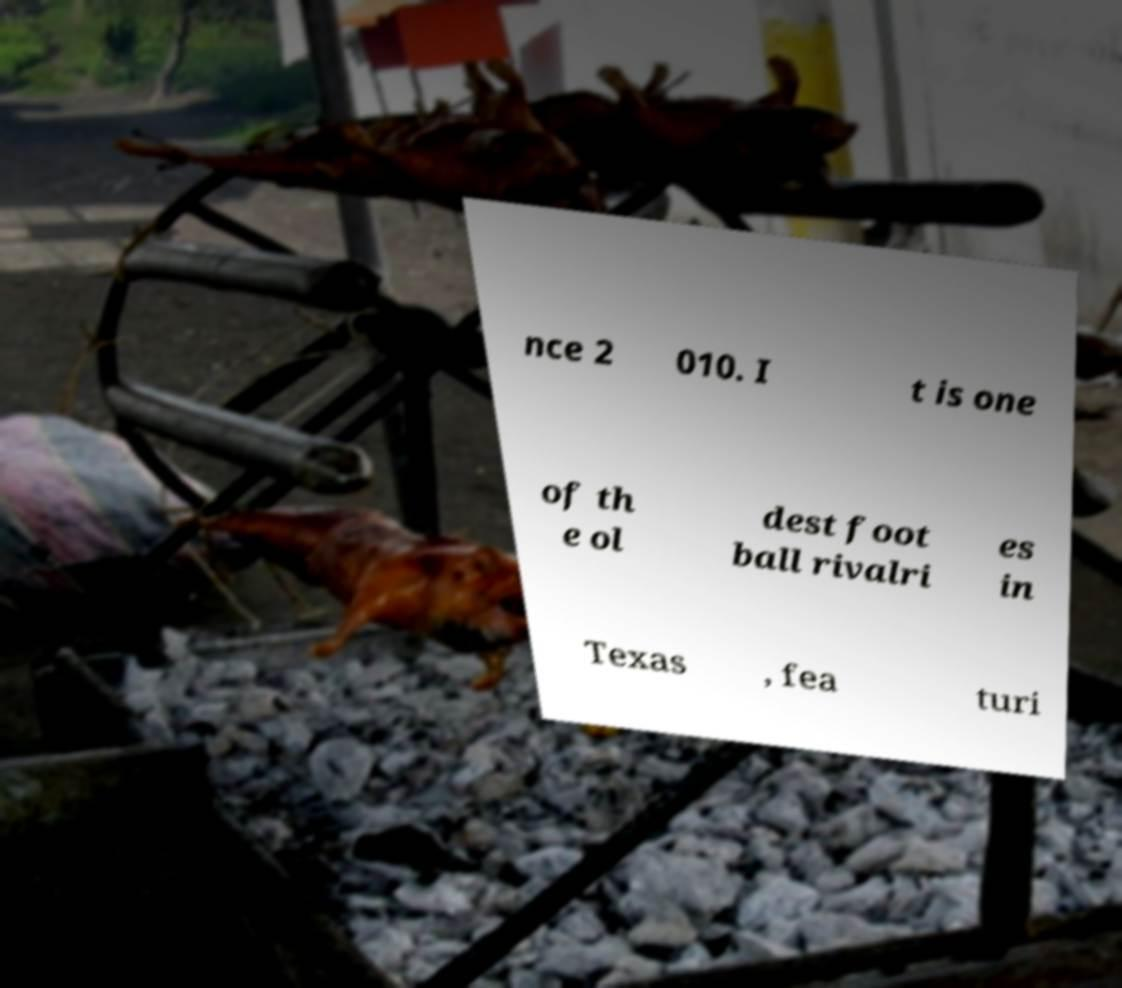Can you read and provide the text displayed in the image?This photo seems to have some interesting text. Can you extract and type it out for me? nce 2 010. I t is one of th e ol dest foot ball rivalri es in Texas , fea turi 